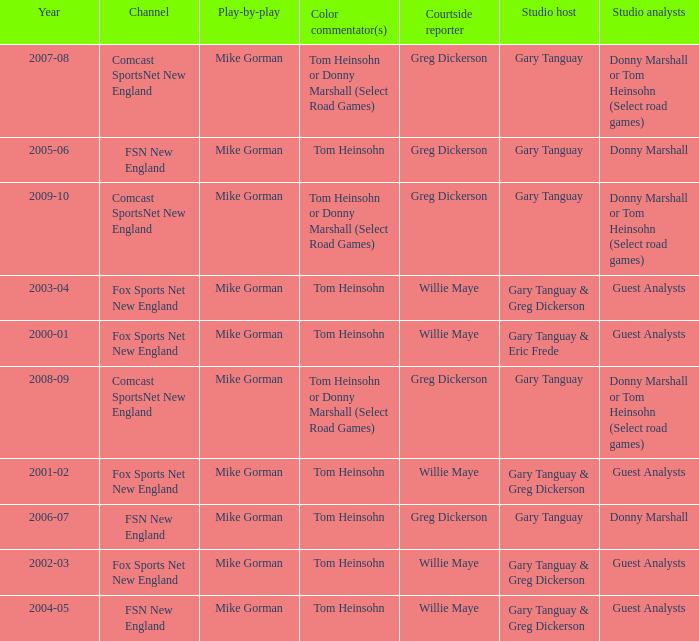WHich Studio analysts has a Studio host of gary tanguay in 2009-10? Donny Marshall or Tom Heinsohn (Select road games). 